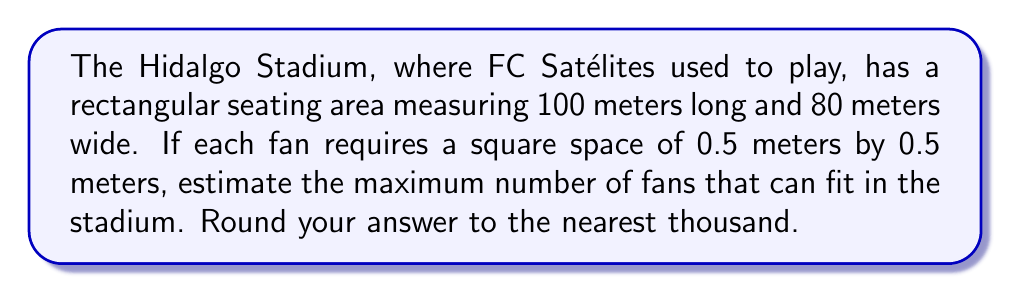Solve this math problem. Let's approach this problem step-by-step:

1. Calculate the total area of the stadium:
   $$ A_{total} = 100 \text{ m} \times 80 \text{ m} = 8000 \text{ m}^2 $$

2. Calculate the area required for each fan:
   $$ A_{fan} = 0.5 \text{ m} \times 0.5 \text{ m} = 0.25 \text{ m}^2 $$

3. Calculate the number of fans that can fit in the stadium:
   $$ N_{fans} = \frac{A_{total}}{A_{fan}} = \frac{8000 \text{ m}^2}{0.25 \text{ m}^2} = 32000 $$

4. Round the result to the nearest thousand:
   32000 rounded to the nearest thousand is 32000.

[asy]
size(200);
draw((0,0)--(100,0)--(100,80)--(0,80)--cycle);
label("100 m", (50,0), S);
label("80 m", (0,40), W);
draw((50,40)--(50.5,40)--(50.5,40.5)--(50,40.5)--cycle);
label("0.5 m", (50.25,40), S, fontsize(8));
label("0.5 m", (50,40.25), W, fontsize(8));
[/asy]
Answer: 32000 fans 